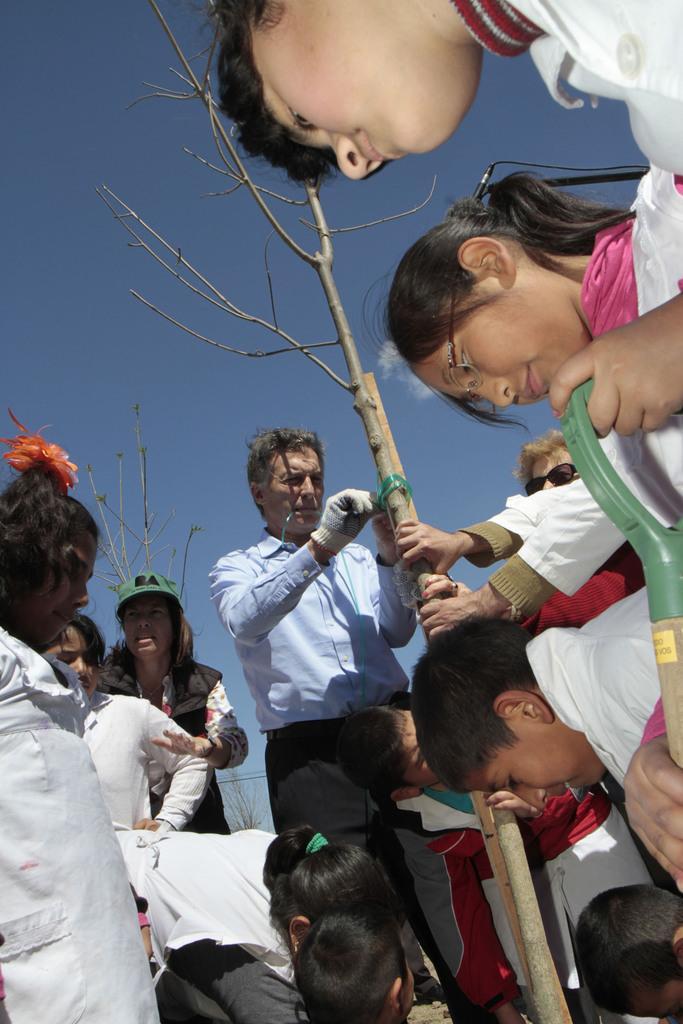In one or two sentences, can you explain what this image depicts? In this image we can see group of persons. In the center of the image there is a person holding a tree. In the background there is a sky and cloud. 